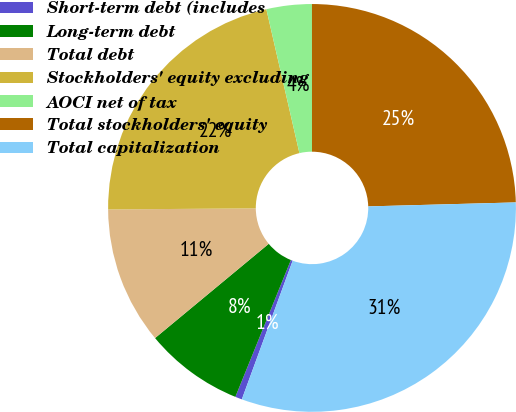Convert chart to OTSL. <chart><loc_0><loc_0><loc_500><loc_500><pie_chart><fcel>Short-term debt (includes<fcel>Long-term debt<fcel>Total debt<fcel>Stockholders' equity excluding<fcel>AOCI net of tax<fcel>Total stockholders' equity<fcel>Total capitalization<nl><fcel>0.54%<fcel>7.85%<fcel>10.9%<fcel>21.53%<fcel>3.59%<fcel>24.58%<fcel>31.03%<nl></chart> 